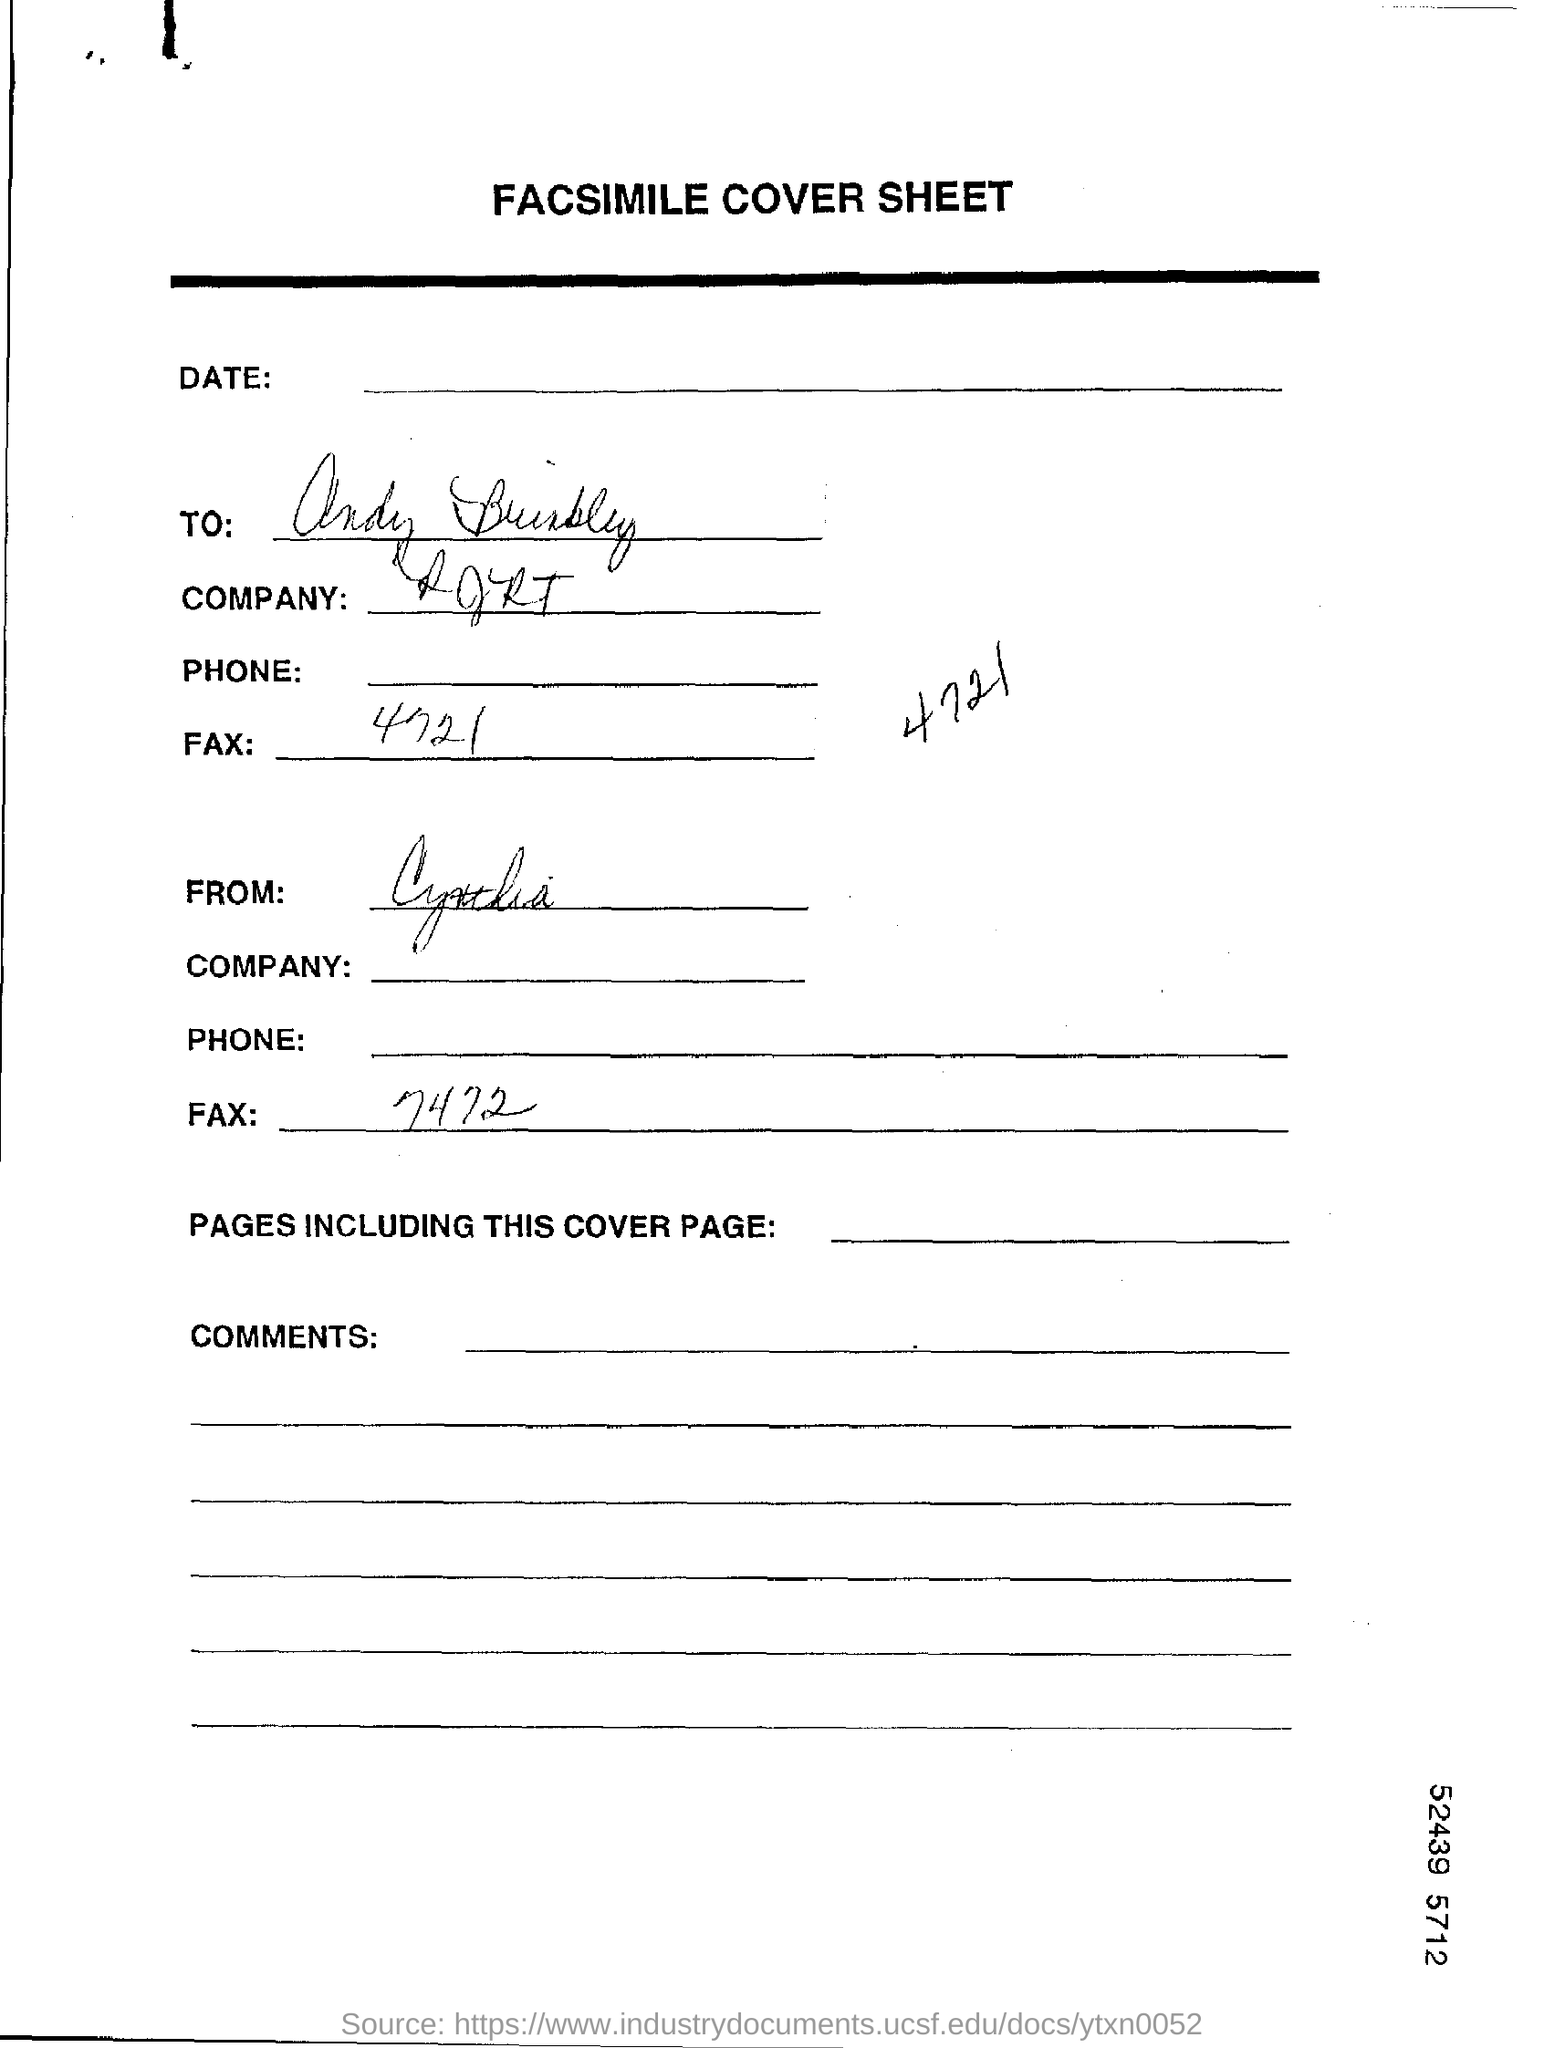What is the heading of the page ?
Your answer should be very brief. Facsimile cover sheet. 